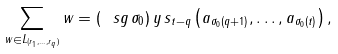Convert formula to latex. <formula><loc_0><loc_0><loc_500><loc_500>\sum _ { w \in L _ { ( r _ { 1 } , \dots , r _ { q } ) } } w = ( \ s g \, \sigma _ { 0 } ) \, y \, s _ { t - q } \left ( a _ { \sigma _ { 0 } ( q + 1 ) } , \dots , a _ { \sigma _ { 0 } ( t ) } \right ) ,</formula> 